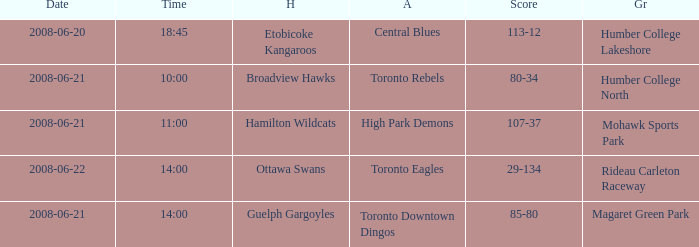What is the Time with a Score that is 80-34? 10:00. 